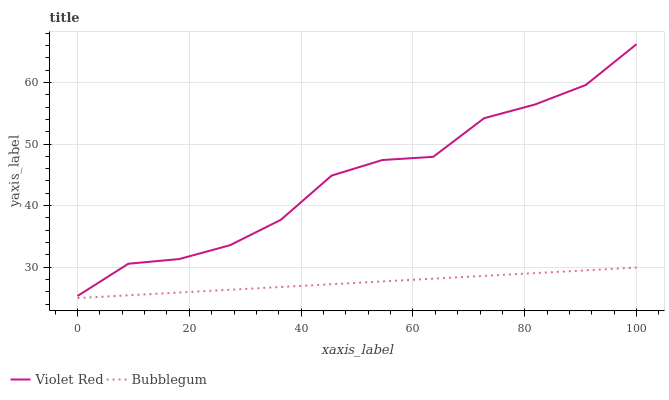Does Bubblegum have the minimum area under the curve?
Answer yes or no. Yes. Does Violet Red have the maximum area under the curve?
Answer yes or no. Yes. Does Bubblegum have the maximum area under the curve?
Answer yes or no. No. Is Bubblegum the smoothest?
Answer yes or no. Yes. Is Violet Red the roughest?
Answer yes or no. Yes. Is Bubblegum the roughest?
Answer yes or no. No. Does Bubblegum have the lowest value?
Answer yes or no. Yes. Does Violet Red have the highest value?
Answer yes or no. Yes. Does Bubblegum have the highest value?
Answer yes or no. No. Is Bubblegum less than Violet Red?
Answer yes or no. Yes. Is Violet Red greater than Bubblegum?
Answer yes or no. Yes. Does Bubblegum intersect Violet Red?
Answer yes or no. No. 